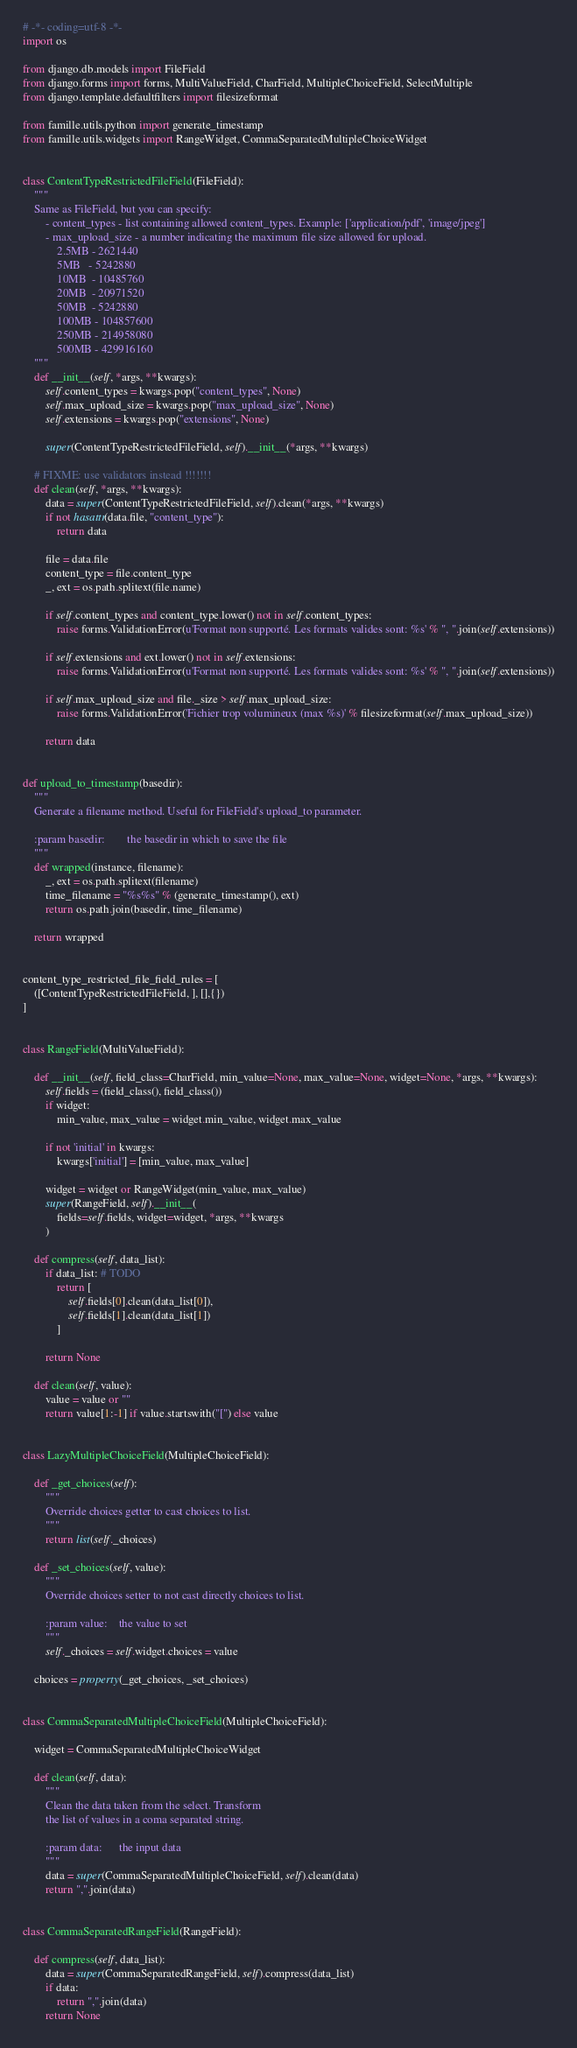Convert code to text. <code><loc_0><loc_0><loc_500><loc_500><_Python_># -*- coding=utf-8 -*-
import os

from django.db.models import FileField
from django.forms import forms, MultiValueField, CharField, MultipleChoiceField, SelectMultiple
from django.template.defaultfilters import filesizeformat

from famille.utils.python import generate_timestamp
from famille.utils.widgets import RangeWidget, CommaSeparatedMultipleChoiceWidget


class ContentTypeRestrictedFileField(FileField):
    """
    Same as FileField, but you can specify:
        - content_types - list containing allowed content_types. Example: ['application/pdf', 'image/jpeg']
        - max_upload_size - a number indicating the maximum file size allowed for upload.
            2.5MB - 2621440
            5MB   - 5242880
            10MB  - 10485760
            20MB  - 20971520
            50MB  - 5242880
            100MB - 104857600
            250MB - 214958080
            500MB - 429916160
    """
    def __init__(self, *args, **kwargs):
        self.content_types = kwargs.pop("content_types", None)
        self.max_upload_size = kwargs.pop("max_upload_size", None)
        self.extensions = kwargs.pop("extensions", None)

        super(ContentTypeRestrictedFileField, self).__init__(*args, **kwargs)

    # FIXME: use validators instead !!!!!!!
    def clean(self, *args, **kwargs):
        data = super(ContentTypeRestrictedFileField, self).clean(*args, **kwargs)
        if not hasattr(data.file, "content_type"):
            return data

        file = data.file
        content_type = file.content_type
        _, ext = os.path.splitext(file.name)

        if self.content_types and content_type.lower() not in self.content_types:
            raise forms.ValidationError(u'Format non supporté. Les formats valides sont: %s' % ", ".join(self.extensions))

        if self.extensions and ext.lower() not in self.extensions:
            raise forms.ValidationError(u'Format non supporté. Les formats valides sont: %s' % ", ".join(self.extensions))

        if self.max_upload_size and file._size > self.max_upload_size:
            raise forms.ValidationError('Fichier trop volumineux (max %s)' % filesizeformat(self.max_upload_size))

        return data


def upload_to_timestamp(basedir):
    """
    Generate a filename method. Useful for FileField's upload_to parameter.

    :param basedir:        the basedir in which to save the file
    """
    def wrapped(instance, filename):
        _, ext = os.path.splitext(filename)
        time_filename = "%s%s" % (generate_timestamp(), ext)
        return os.path.join(basedir, time_filename)

    return wrapped


content_type_restricted_file_field_rules = [
    ([ContentTypeRestrictedFileField, ], [],{})
]


class RangeField(MultiValueField):

    def __init__(self, field_class=CharField, min_value=None, max_value=None, widget=None, *args, **kwargs):
        self.fields = (field_class(), field_class())
        if widget:
            min_value, max_value = widget.min_value, widget.max_value

        if not 'initial' in kwargs:
            kwargs['initial'] = [min_value, max_value]

        widget = widget or RangeWidget(min_value, max_value)
        super(RangeField, self).__init__(
            fields=self.fields, widget=widget, *args, **kwargs
        )

    def compress(self, data_list):
        if data_list: # TODO
            return [
                self.fields[0].clean(data_list[0]),
                self.fields[1].clean(data_list[1])
            ]

        return None

    def clean(self, value):
        value = value or ""
        return value[1:-1] if value.startswith("[") else value


class LazyMultipleChoiceField(MultipleChoiceField):

    def _get_choices(self):
        """
        Override choices getter to cast choices to list.
        """
        return list(self._choices)

    def _set_choices(self, value):
        """
        Override choices setter to not cast directly choices to list.

        :param value:    the value to set
        """
        self._choices = self.widget.choices = value

    choices = property(_get_choices, _set_choices)


class CommaSeparatedMultipleChoiceField(MultipleChoiceField):

    widget = CommaSeparatedMultipleChoiceWidget

    def clean(self, data):
        """
        Clean the data taken from the select. Transform
        the list of values in a coma separated string.

        :param data:      the input data
        """
        data = super(CommaSeparatedMultipleChoiceField, self).clean(data)
        return ",".join(data)


class CommaSeparatedRangeField(RangeField):

    def compress(self, data_list):
        data = super(CommaSeparatedRangeField, self).compress(data_list)
        if data:
            return ",".join(data)
        return None
</code> 